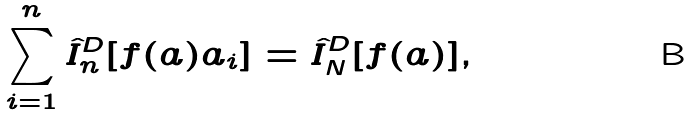<formula> <loc_0><loc_0><loc_500><loc_500>\sum _ { i = 1 } ^ { n } \hat { I } _ { n } ^ { D } [ f ( a ) a _ { i } ] = \hat { I } _ { N } ^ { D } [ f ( a ) ] ,</formula> 